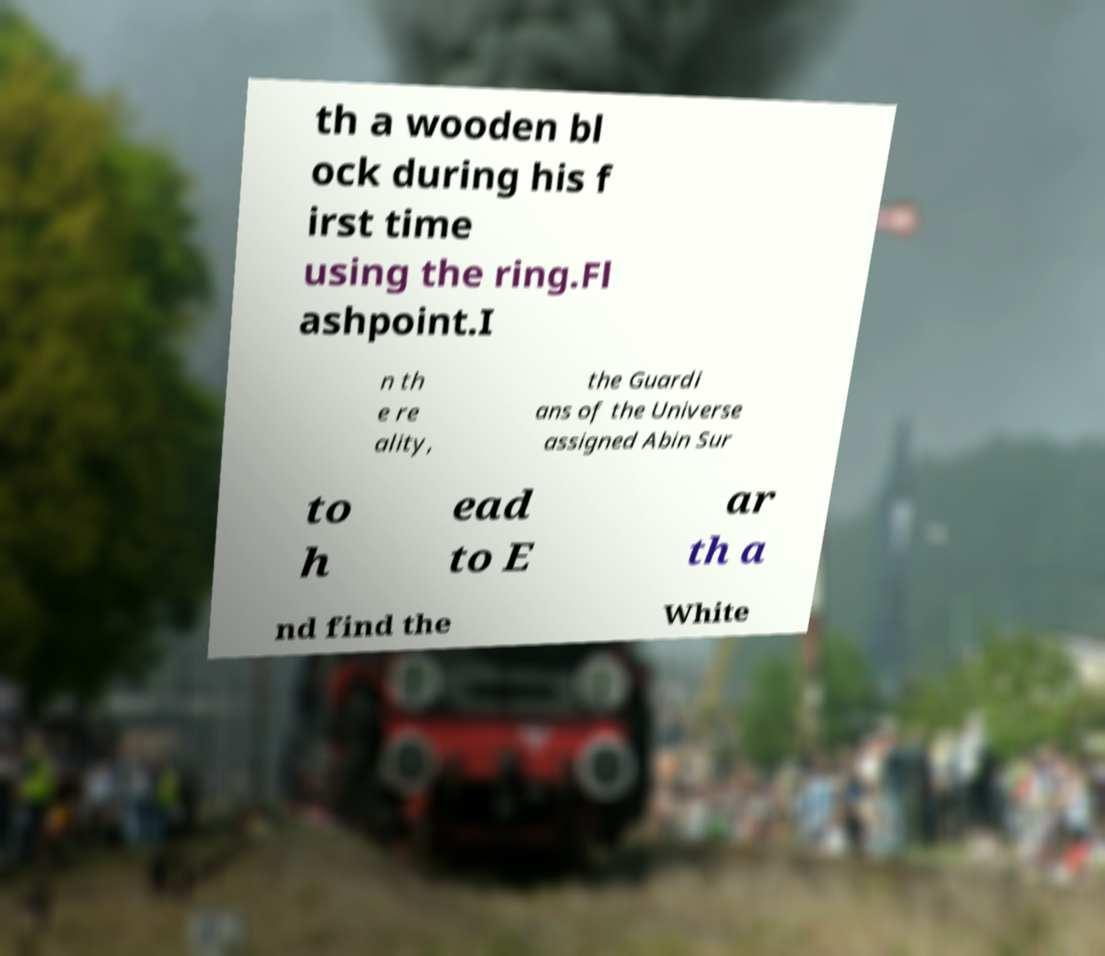Can you read and provide the text displayed in the image?This photo seems to have some interesting text. Can you extract and type it out for me? th a wooden bl ock during his f irst time using the ring.Fl ashpoint.I n th e re ality, the Guardi ans of the Universe assigned Abin Sur to h ead to E ar th a nd find the White 